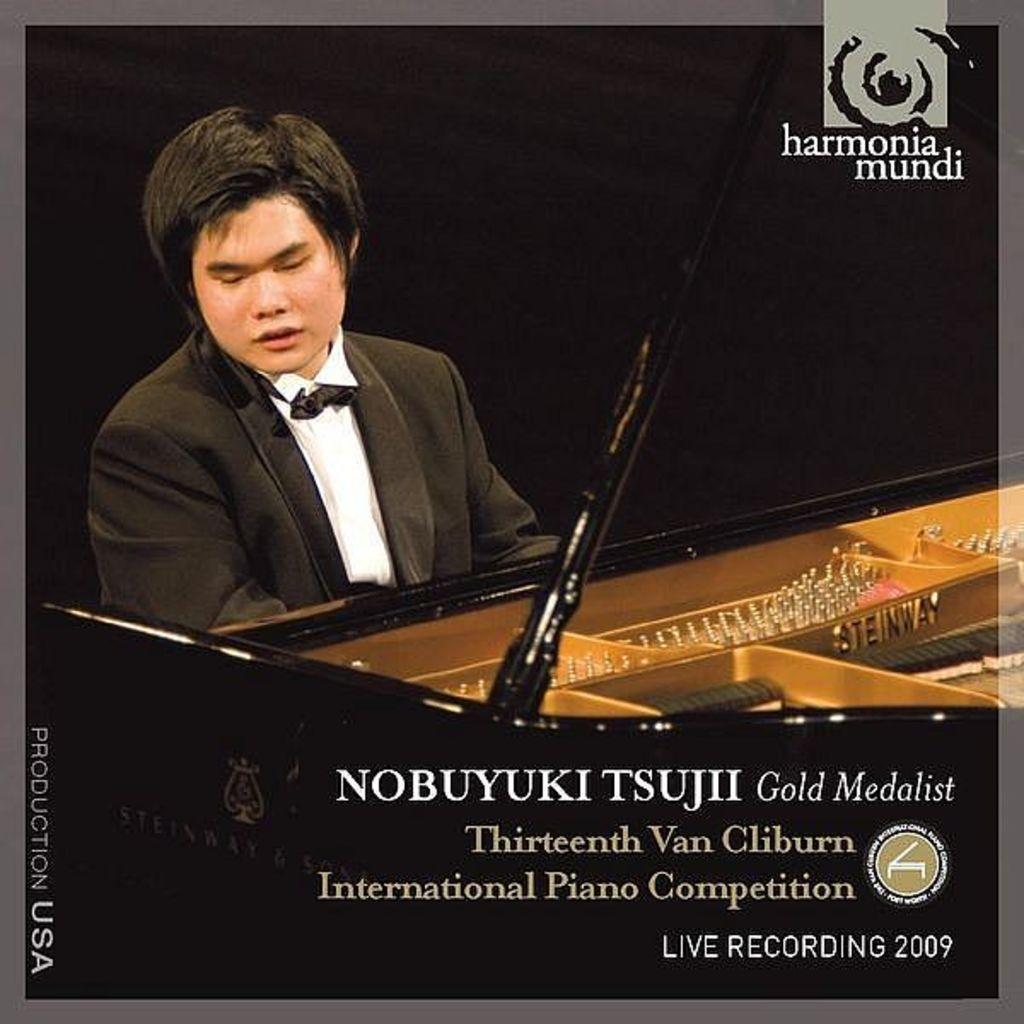Could you give a brief overview of what you see in this image? In the poster there is a man with black jacket and white shirt is sitting and in front of him there is a piano. At the right bottom of the image there is something written on it. At the top right of the image there is a logo. 